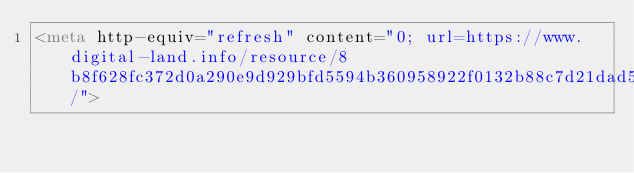<code> <loc_0><loc_0><loc_500><loc_500><_HTML_><meta http-equiv="refresh" content="0; url=https://www.digital-land.info/resource/8b8f628fc372d0a290e9d929bfd5594b360958922f0132b88c7d21dad56e24e7/">
</code> 